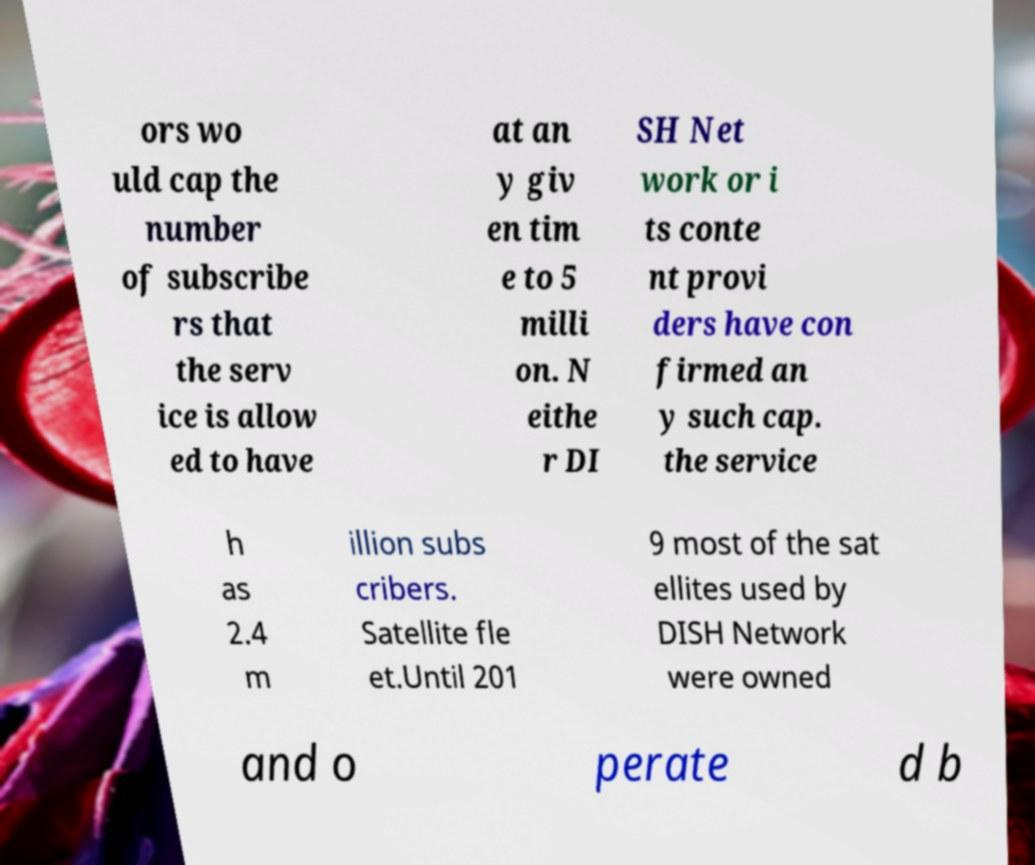Could you extract and type out the text from this image? ors wo uld cap the number of subscribe rs that the serv ice is allow ed to have at an y giv en tim e to 5 milli on. N eithe r DI SH Net work or i ts conte nt provi ders have con firmed an y such cap. the service h as 2.4 m illion subs cribers. Satellite fle et.Until 201 9 most of the sat ellites used by DISH Network were owned and o perate d b 